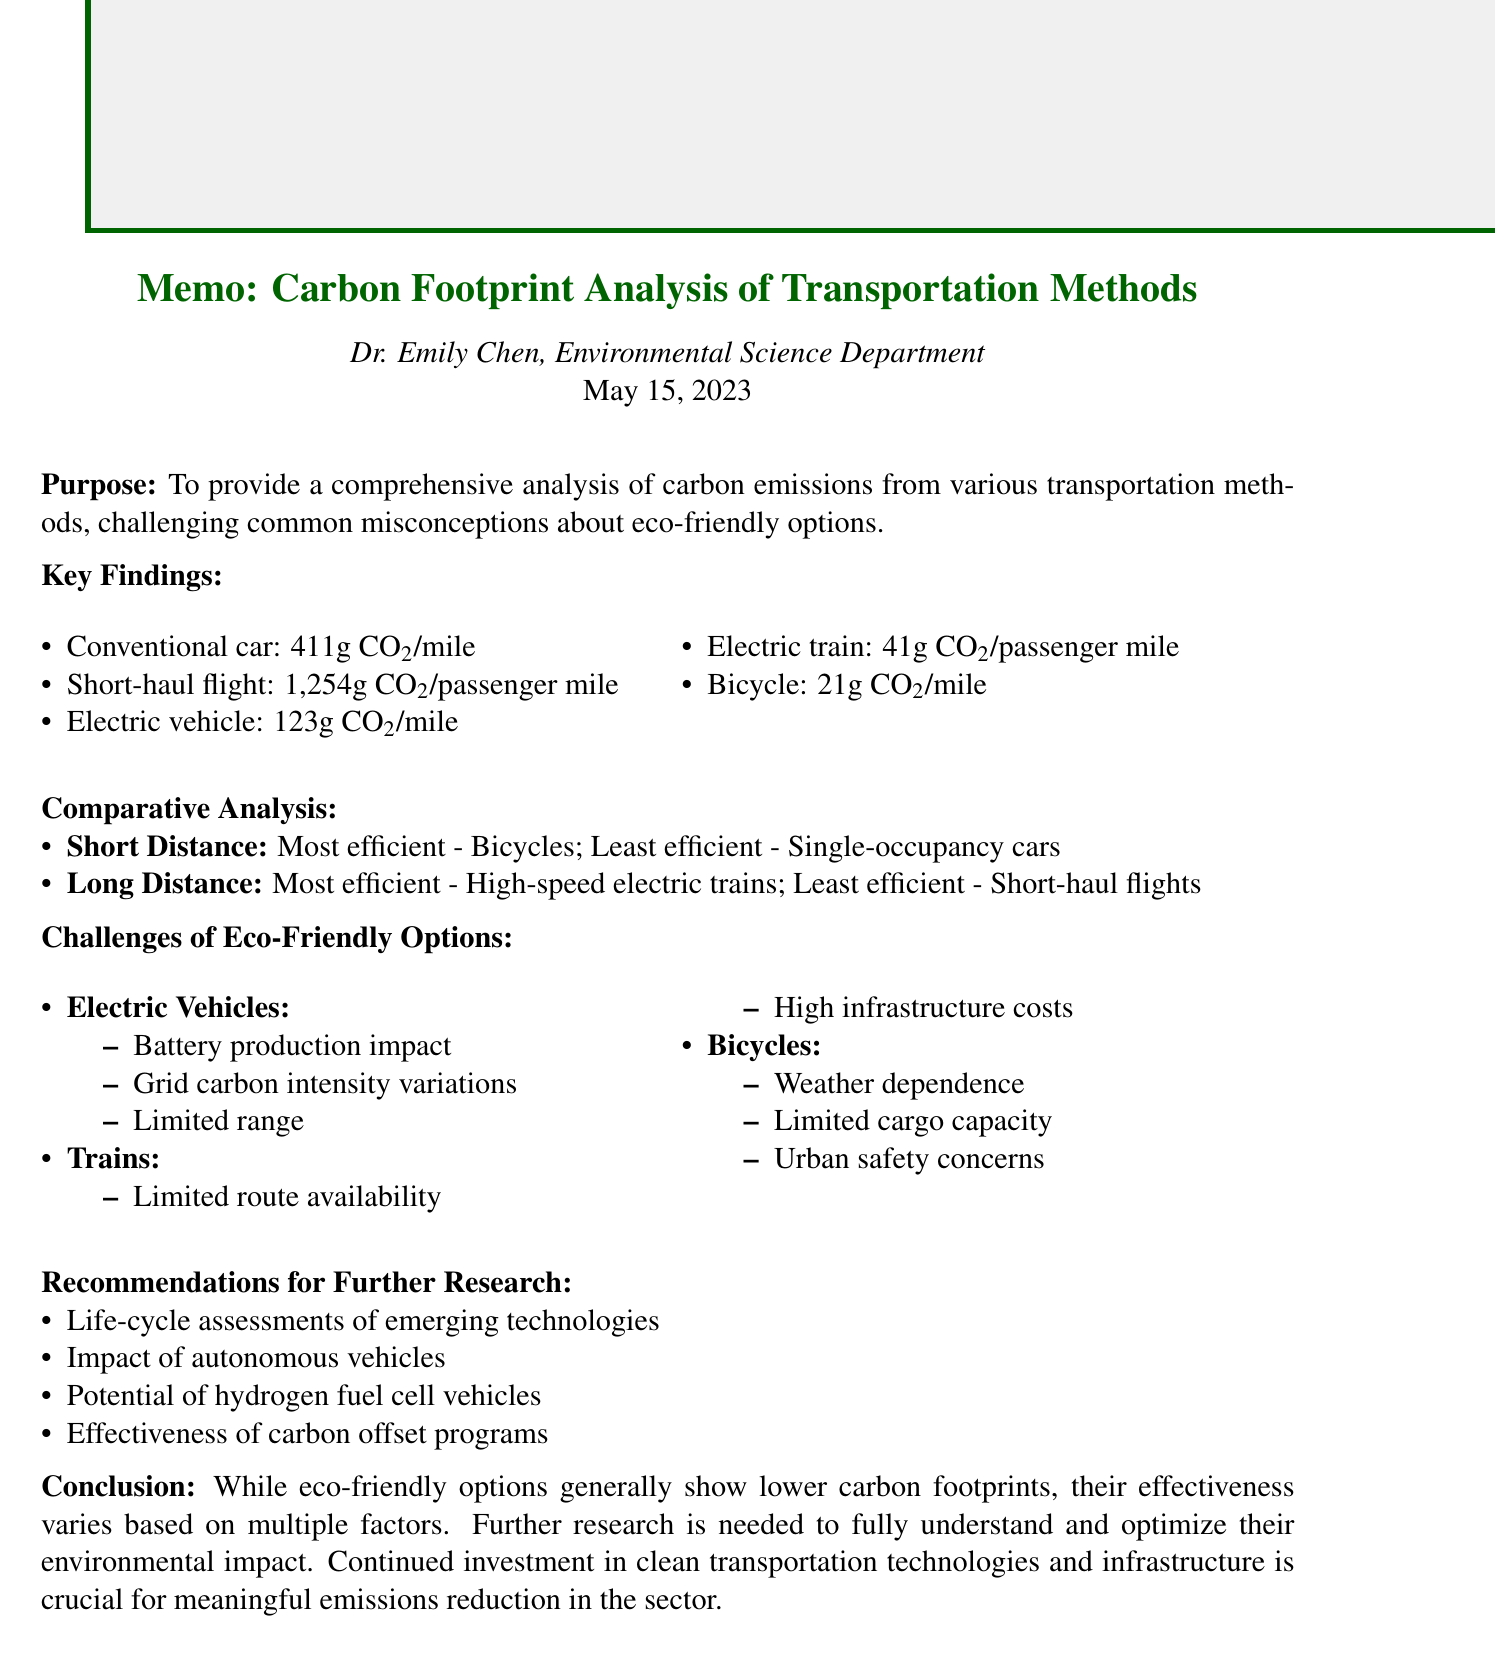What is the purpose of the memo? The purpose is to provide a comprehensive analysis of carbon emissions from various transportation methods, challenging common misconceptions about eco-friendly options.
Answer: To provide a comprehensive analysis of carbon emissions from various transportation methods, challenging common misconceptions about eco-friendly options Who is the author of the memo? The author is mentioned at the beginning of the document.
Answer: Dr. Emily Chen What is the average emission for conventional cars? The average emission for conventional cars is specified in the conventional transportation section.
Answer: 411 grams CO2 per mile What are the challenges of electric vehicles? The challenges are listed under the eco-friendly transportation section.
Answer: Battery production environmental impact, Electricity grid carbon intensity variations, Limited range for long-distance travel Which transportation method has the lowest emissions for short-distance travel? The most efficient method for short-distance travel is highlighted in the comparative analysis section.
Answer: Bicycles What is recommended for further research? The document lists multiple recommendations under the section dedicated to future research.
Answer: Life-cycle assessments of emerging transportation technologies What is the annual emission for an average driver? The annual emissions are provided in the conventional transportation section.
Answer: 4.6 metric tons CO2 for average driver What is the emission per passenger mile for electric trains? This information is found in the eco-friendly transportation section of the document.
Answer: 41 grams CO2 per passenger mile 